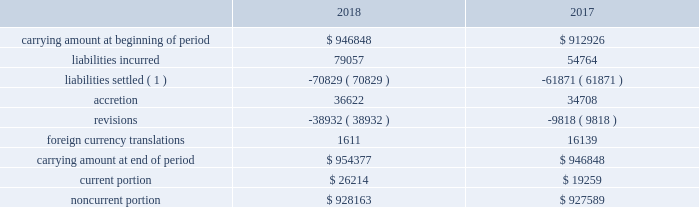Eog utilized average prices per acre from comparable market transactions and estimated discounted cash flows as the basis for determining the fair value of unproved and proved properties , respectively , received in non-cash property exchanges .
See note 10 .
Fair value of debt .
At december 31 , 2018 and 2017 , respectively , eog had outstanding $ 6040 million and $ 6390 million aggregate principal amount of senior notes , which had estimated fair values of approximately $ 6027 million and $ 6602 million , respectively .
The estimated fair value of debt was based upon quoted market prices and , where such prices were not available , other observable ( level 2 ) inputs regarding interest rates available to eog at year-end .
14 .
Accounting for certain long-lived assets eog reviews its proved oil and gas properties for impairment purposes by comparing the expected undiscounted future cash flows at a depreciation , depletion and amortization group level to the unamortized capitalized cost of the asset .
The carrying values for assets determined to be impaired were adjusted to estimated fair value using the income approach described in the fair value measurement topic of the asc .
In certain instances , eog utilizes accepted offers from third-party purchasers as the basis for determining fair value .
During 2018 , proved oil and gas properties with a carrying amount of $ 139 million were written down to their fair value of $ 18 million , resulting in pretax impairment charges of $ 121 million .
During 2017 , proved oil and gas properties with a carrying amount of $ 370 million were written down to their fair value of $ 146 million , resulting in pretax impairment charges of $ 224 million .
Impairments in 2018 , 2017 and 2016 included domestic legacy natural gas assets .
Amortization and impairments of unproved oil and gas property costs , including amortization of capitalized interest , were $ 173 million , $ 211 million and $ 291 million during 2018 , 2017 and 2016 , respectively .
15 .
Asset retirement obligations the table presents the reconciliation of the beginning and ending aggregate carrying amounts of short-term and long-term legal obligations associated with the retirement of property , plant and equipment for the years ended december 31 , 2018 and 2017 ( in thousands ) : .
( 1 ) includes settlements related to asset sales .
The current and noncurrent portions of eog's asset retirement obligations are included in current liabilities - other and other liabilities , respectively , on the consolidated balance sheets. .
What is the percentage of the carrying amount of proved oil and gas properties concerning the total carrying amount in 2017? 
Rationale: it is the carrying amount of proved oil and gas properties in millions divided by the total carrying amount , also in millions , then turned into a percentage .
Computations: (370 / (912926 / 1000))
Answer: 0.40529. Eog utilized average prices per acre from comparable market transactions and estimated discounted cash flows as the basis for determining the fair value of unproved and proved properties , respectively , received in non-cash property exchanges .
See note 10 .
Fair value of debt .
At december 31 , 2018 and 2017 , respectively , eog had outstanding $ 6040 million and $ 6390 million aggregate principal amount of senior notes , which had estimated fair values of approximately $ 6027 million and $ 6602 million , respectively .
The estimated fair value of debt was based upon quoted market prices and , where such prices were not available , other observable ( level 2 ) inputs regarding interest rates available to eog at year-end .
14 .
Accounting for certain long-lived assets eog reviews its proved oil and gas properties for impairment purposes by comparing the expected undiscounted future cash flows at a depreciation , depletion and amortization group level to the unamortized capitalized cost of the asset .
The carrying values for assets determined to be impaired were adjusted to estimated fair value using the income approach described in the fair value measurement topic of the asc .
In certain instances , eog utilizes accepted offers from third-party purchasers as the basis for determining fair value .
During 2018 , proved oil and gas properties with a carrying amount of $ 139 million were written down to their fair value of $ 18 million , resulting in pretax impairment charges of $ 121 million .
During 2017 , proved oil and gas properties with a carrying amount of $ 370 million were written down to their fair value of $ 146 million , resulting in pretax impairment charges of $ 224 million .
Impairments in 2018 , 2017 and 2016 included domestic legacy natural gas assets .
Amortization and impairments of unproved oil and gas property costs , including amortization of capitalized interest , were $ 173 million , $ 211 million and $ 291 million during 2018 , 2017 and 2016 , respectively .
15 .
Asset retirement obligations the table presents the reconciliation of the beginning and ending aggregate carrying amounts of short-term and long-term legal obligations associated with the retirement of property , plant and equipment for the years ended december 31 , 2018 and 2017 ( in thousands ) : .
( 1 ) includes settlements related to asset sales .
The current and noncurrent portions of eog's asset retirement obligations are included in current liabilities - other and other liabilities , respectively , on the consolidated balance sheets. .
What is the increase observed in the liabilities incurred during 2017 and 2018? 
Rationale: it is the liabilities incurred in 2018 divided by the 2017's , then subtracted 1 and turned into a percentage .
Computations: ((79057 / 54764) - 1)
Answer: 0.44359. 